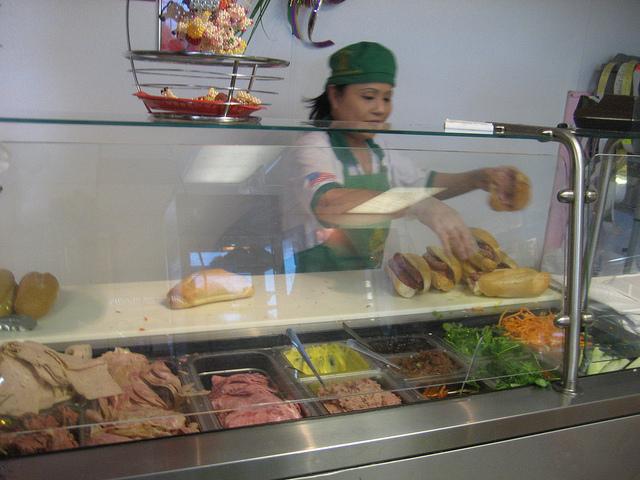Is this a doughnut shop?
Concise answer only. No. Is this a chocolate shop?
Give a very brief answer. No. What kind of food is this?
Concise answer only. Deli. Are the man's arms folded?
Quick response, please. No. Is she wearing a hat?
Be succinct. Yes. What type of food is she making?
Keep it brief. Hot dogs. 